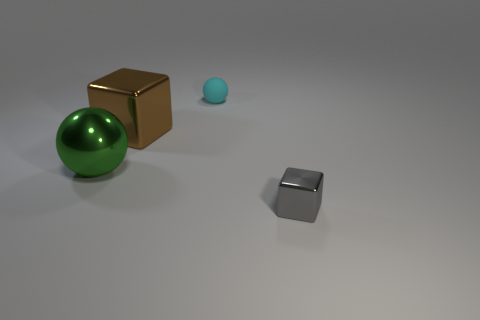Add 4 tiny gray metallic blocks. How many objects exist? 8 Add 3 cyan matte balls. How many cyan matte balls are left? 4 Add 2 big brown cubes. How many big brown cubes exist? 3 Subtract 0 blue cylinders. How many objects are left? 4 Subtract all small gray things. Subtract all matte objects. How many objects are left? 2 